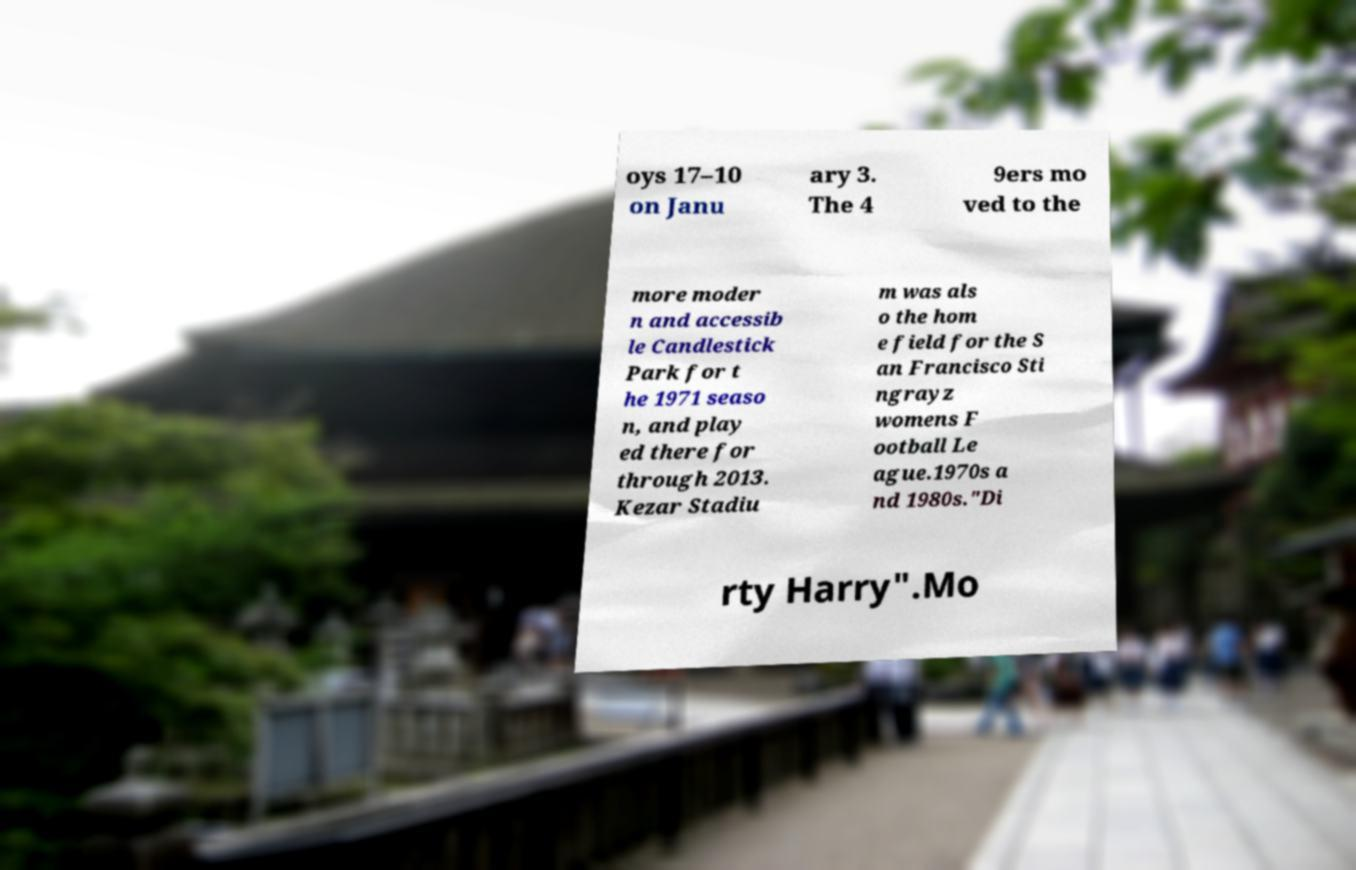Please identify and transcribe the text found in this image. oys 17–10 on Janu ary 3. The 4 9ers mo ved to the more moder n and accessib le Candlestick Park for t he 1971 seaso n, and play ed there for through 2013. Kezar Stadiu m was als o the hom e field for the S an Francisco Sti ngrayz womens F ootball Le ague.1970s a nd 1980s."Di rty Harry".Mo 